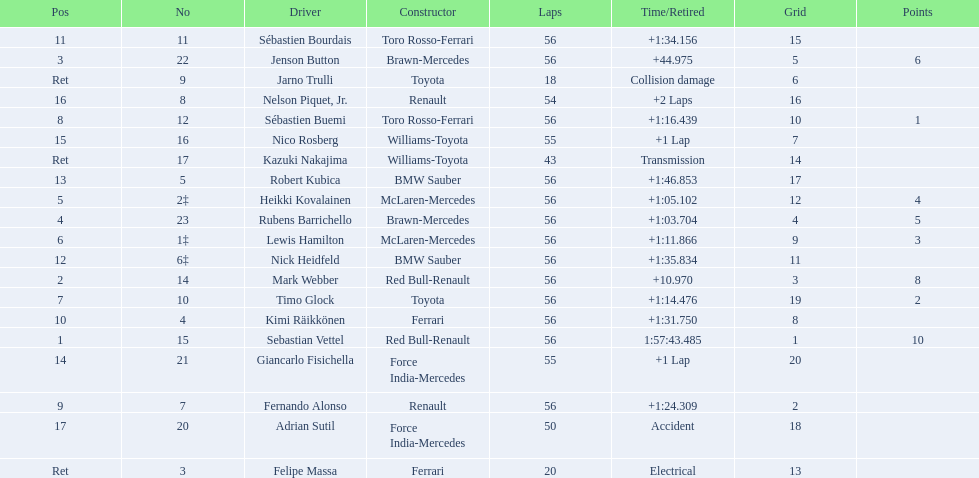Which drive retired because of electrical issues? Felipe Massa. Which driver retired due to accident? Adrian Sutil. Which driver retired due to collision damage? Jarno Trulli. 